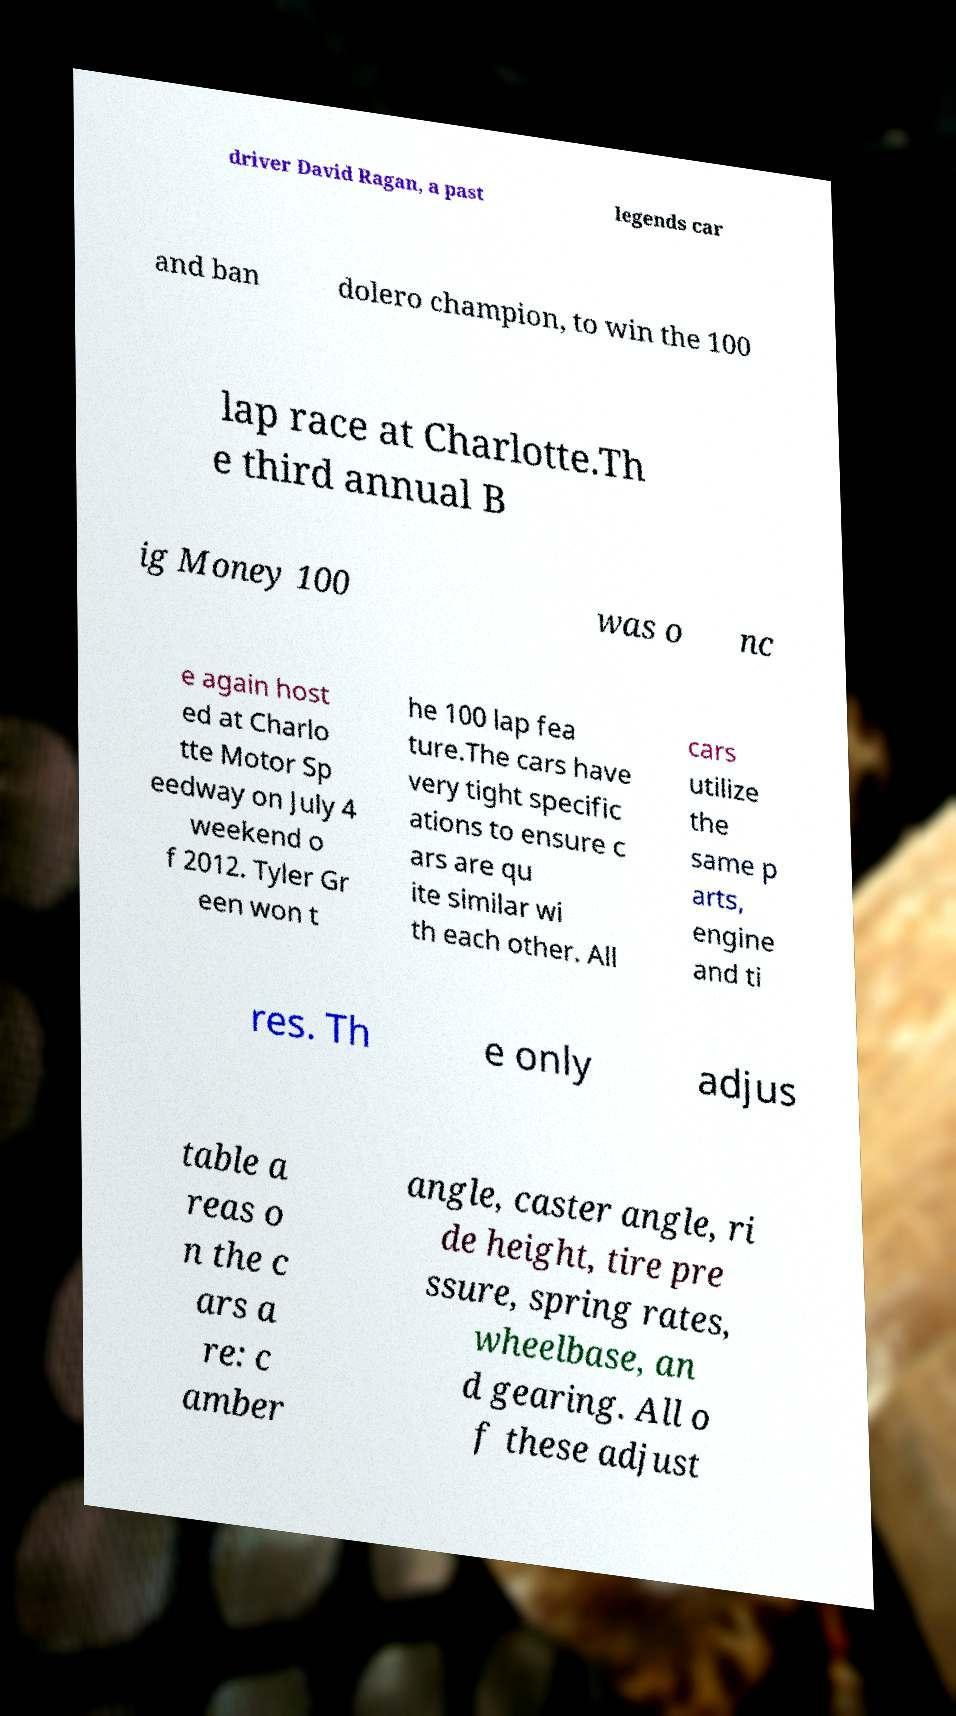There's text embedded in this image that I need extracted. Can you transcribe it verbatim? driver David Ragan, a past legends car and ban dolero champion, to win the 100 lap race at Charlotte.Th e third annual B ig Money 100 was o nc e again host ed at Charlo tte Motor Sp eedway on July 4 weekend o f 2012. Tyler Gr een won t he 100 lap fea ture.The cars have very tight specific ations to ensure c ars are qu ite similar wi th each other. All cars utilize the same p arts, engine and ti res. Th e only adjus table a reas o n the c ars a re: c amber angle, caster angle, ri de height, tire pre ssure, spring rates, wheelbase, an d gearing. All o f these adjust 